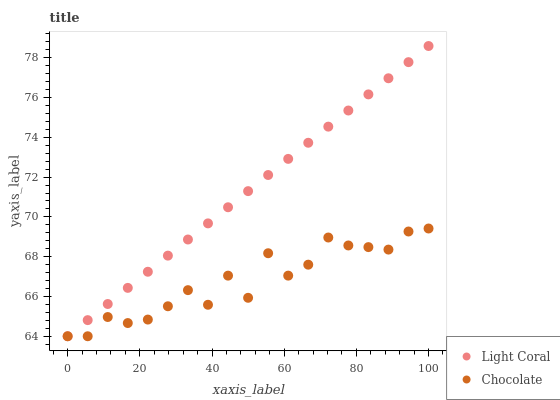Does Chocolate have the minimum area under the curve?
Answer yes or no. Yes. Does Light Coral have the maximum area under the curve?
Answer yes or no. Yes. Does Chocolate have the maximum area under the curve?
Answer yes or no. No. Is Light Coral the smoothest?
Answer yes or no. Yes. Is Chocolate the roughest?
Answer yes or no. Yes. Is Chocolate the smoothest?
Answer yes or no. No. Does Light Coral have the lowest value?
Answer yes or no. Yes. Does Light Coral have the highest value?
Answer yes or no. Yes. Does Chocolate have the highest value?
Answer yes or no. No. Does Light Coral intersect Chocolate?
Answer yes or no. Yes. Is Light Coral less than Chocolate?
Answer yes or no. No. Is Light Coral greater than Chocolate?
Answer yes or no. No. 